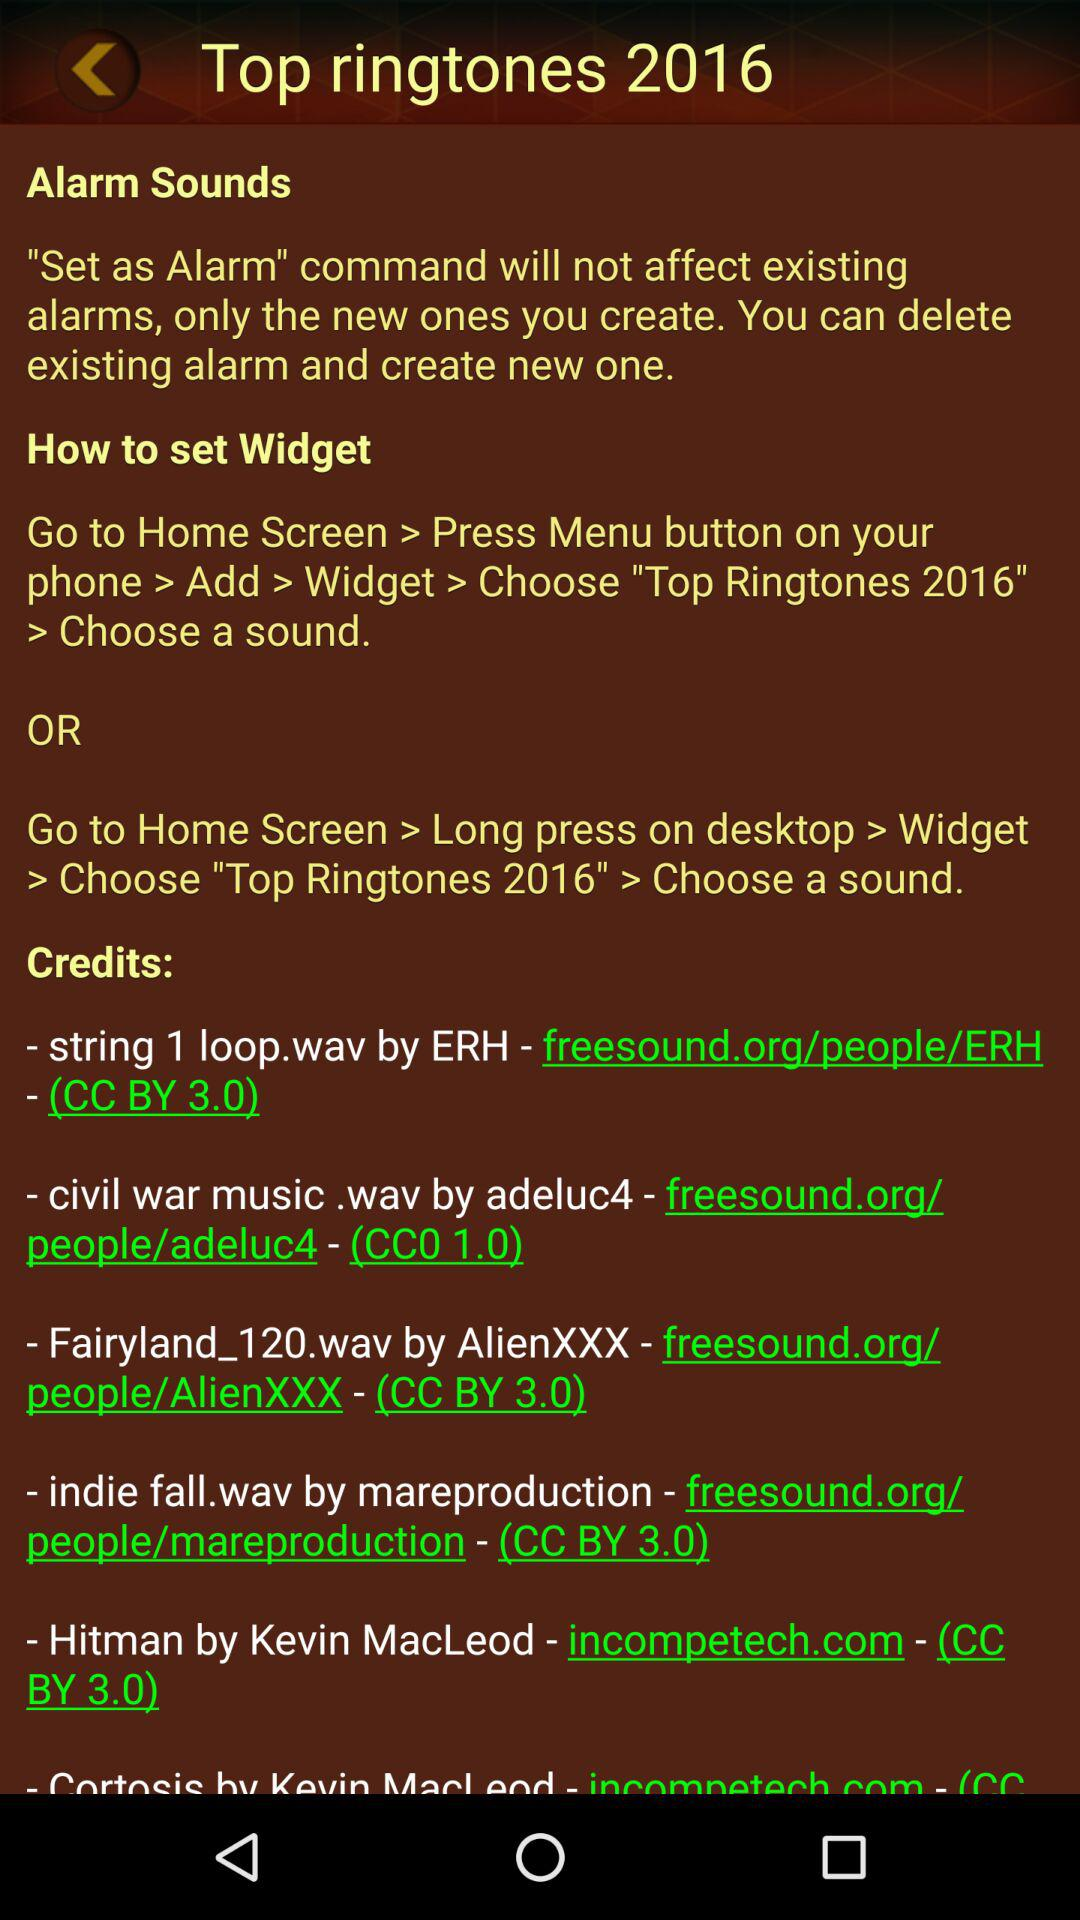How many of the sounds in the credits section are licensed under the CC BY 3.0 license?
Answer the question using a single word or phrase. 4 